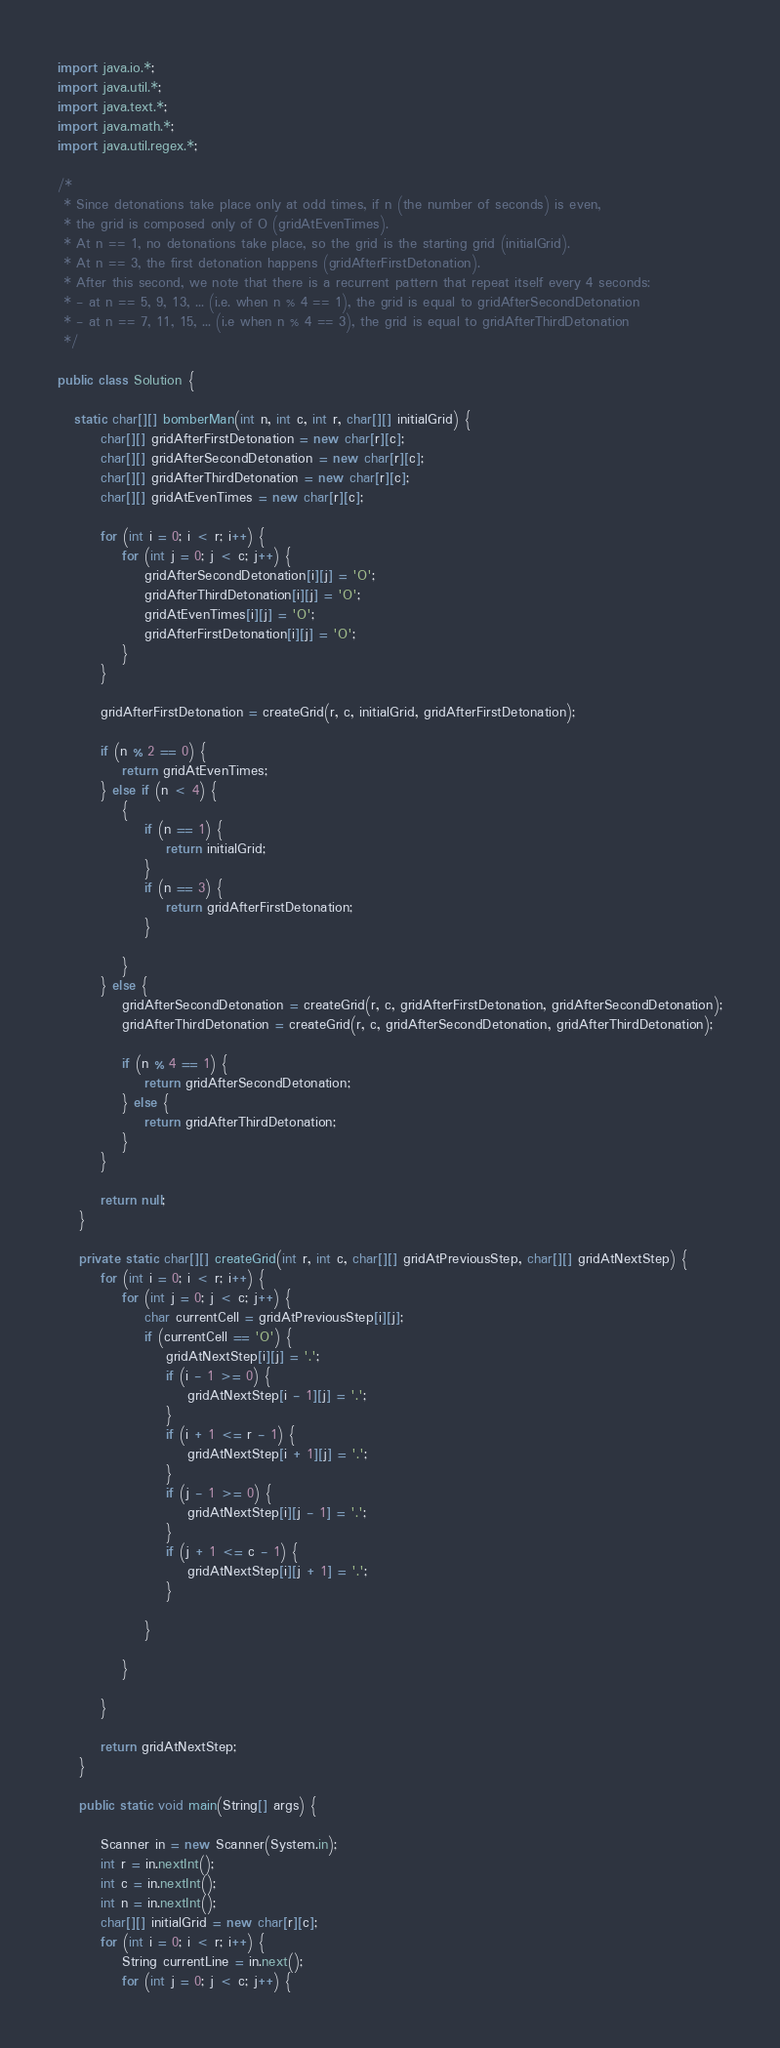Convert code to text. <code><loc_0><loc_0><loc_500><loc_500><_Java_>import java.io.*;
import java.util.*;
import java.text.*;
import java.math.*;
import java.util.regex.*;

/*
 * Since detonations take place only at odd times, if n (the number of seconds) is even,
 * the grid is composed only of O (gridAtEvenTimes).
 * At n == 1, no detonations take place, so the grid is the starting grid (initialGrid).
 * At n == 3, the first detonation happens (gridAfterFirstDetonation).
 * After this second, we note that there is a recurrent pattern that repeat itself every 4 seconds: 
 * - at n == 5, 9, 13, ... (i.e. when n % 4 == 1), the grid is equal to gridAfterSecondDetonation
 * - at n == 7, 11, 15, ... (i.e when n % 4 == 3), the grid is equal to gridAfterThirdDetonation
 */

public class Solution {

   static char[][] bomberMan(int n, int c, int r, char[][] initialGrid) {
		char[][] gridAfterFirstDetonation = new char[r][c];
		char[][] gridAfterSecondDetonation = new char[r][c];
		char[][] gridAfterThirdDetonation = new char[r][c];
		char[][] gridAtEvenTimes = new char[r][c];

		for (int i = 0; i < r; i++) {
			for (int j = 0; j < c; j++) {
				gridAfterSecondDetonation[i][j] = 'O';
				gridAfterThirdDetonation[i][j] = 'O';
				gridAtEvenTimes[i][j] = 'O';
				gridAfterFirstDetonation[i][j] = 'O';
			}
		}

		gridAfterFirstDetonation = createGrid(r, c, initialGrid, gridAfterFirstDetonation);

		if (n % 2 == 0) {
			return gridAtEvenTimes;
		} else if (n < 4) {
			{
				if (n == 1) {
					return initialGrid;
				}
				if (n == 3) {
					return gridAfterFirstDetonation;
				}

			}
		} else {
			gridAfterSecondDetonation = createGrid(r, c, gridAfterFirstDetonation, gridAfterSecondDetonation);
			gridAfterThirdDetonation = createGrid(r, c, gridAfterSecondDetonation, gridAfterThirdDetonation);

			if (n % 4 == 1) {
				return gridAfterSecondDetonation;
			} else {
				return gridAfterThirdDetonation;
			}
		}

		return null;
	}

	private static char[][] createGrid(int r, int c, char[][] gridAtPreviousStep, char[][] gridAtNextStep) {
		for (int i = 0; i < r; i++) {
			for (int j = 0; j < c; j++) {
				char currentCell = gridAtPreviousStep[i][j];
				if (currentCell == 'O') {
					gridAtNextStep[i][j] = '.';
					if (i - 1 >= 0) {
						gridAtNextStep[i - 1][j] = '.';
					}
					if (i + 1 <= r - 1) {
						gridAtNextStep[i + 1][j] = '.';
					}
					if (j - 1 >= 0) {
						gridAtNextStep[i][j - 1] = '.';
					}
					if (j + 1 <= c - 1) {
						gridAtNextStep[i][j + 1] = '.';
					}

				}

			}

		}

		return gridAtNextStep;
	}

	public static void main(String[] args) {

		Scanner in = new Scanner(System.in);
		int r = in.nextInt();
		int c = in.nextInt();
		int n = in.nextInt();
		char[][] initialGrid = new char[r][c];
		for (int i = 0; i < r; i++) {
			String currentLine = in.next();
			for (int j = 0; j < c; j++) {</code> 